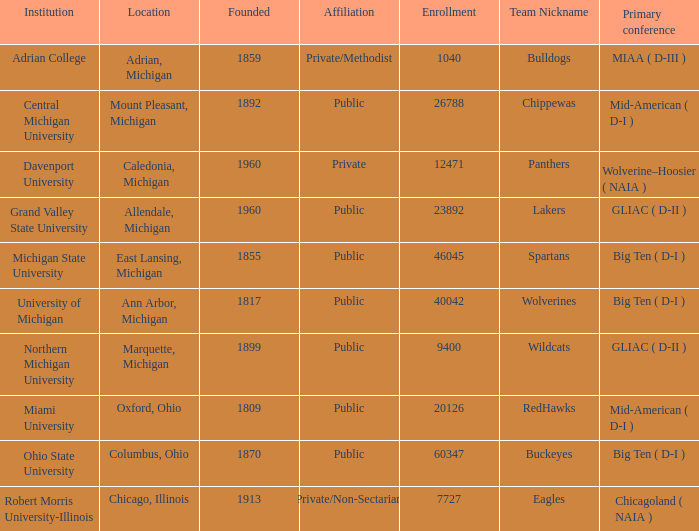What is the nickname of the Adrian, Michigan team? Bulldogs. 